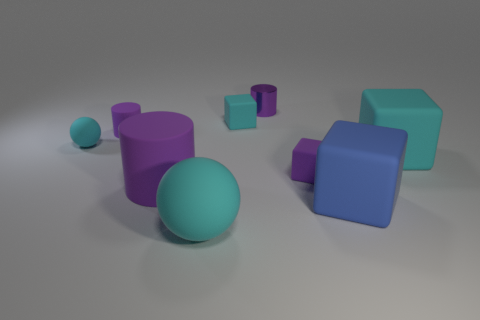Subtract all small cyan cubes. How many cubes are left? 3 Subtract all purple blocks. How many blocks are left? 3 Subtract all cylinders. How many objects are left? 6 Subtract 1 spheres. How many spheres are left? 1 Subtract all cyan cubes. Subtract all blue objects. How many objects are left? 6 Add 5 small cyan rubber things. How many small cyan rubber things are left? 7 Add 6 small gray matte spheres. How many small gray matte spheres exist? 6 Subtract 2 purple cylinders. How many objects are left? 7 Subtract all yellow spheres. Subtract all green cylinders. How many spheres are left? 2 Subtract all blue balls. How many brown blocks are left? 0 